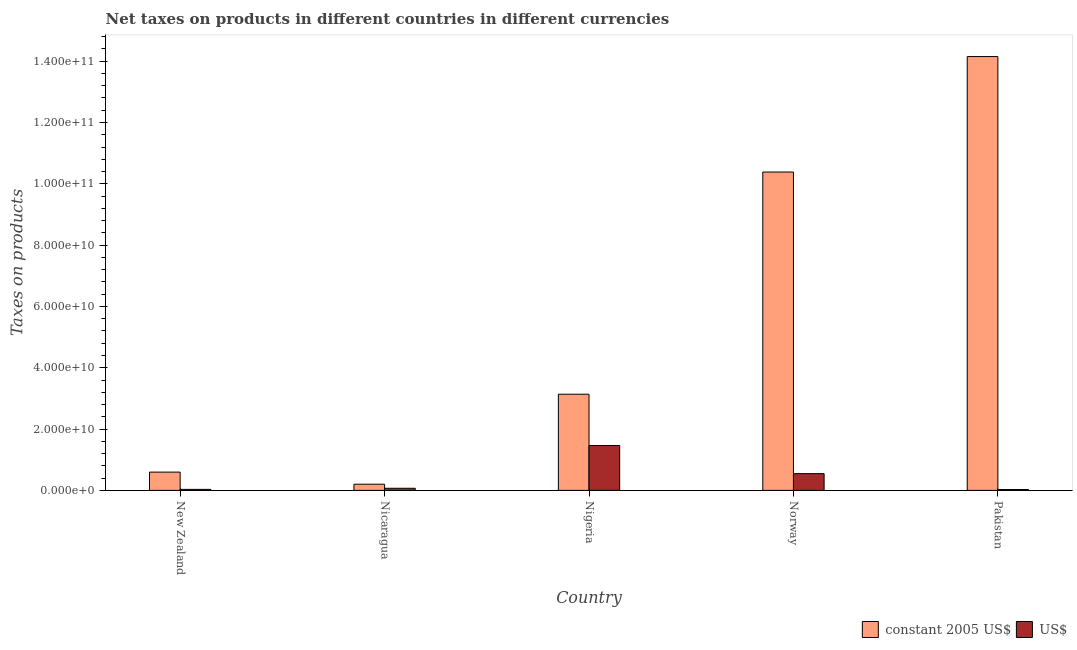How many different coloured bars are there?
Ensure brevity in your answer.  2. Are the number of bars per tick equal to the number of legend labels?
Your response must be concise. Yes. How many bars are there on the 3rd tick from the left?
Keep it short and to the point. 2. What is the label of the 1st group of bars from the left?
Keep it short and to the point. New Zealand. In how many cases, is the number of bars for a given country not equal to the number of legend labels?
Provide a short and direct response. 0. What is the net taxes in us$ in Nicaragua?
Your answer should be very brief. 6.93e+08. Across all countries, what is the maximum net taxes in constant 2005 us$?
Your answer should be compact. 1.42e+11. Across all countries, what is the minimum net taxes in constant 2005 us$?
Make the answer very short. 2.01e+09. In which country was the net taxes in constant 2005 us$ maximum?
Your answer should be very brief. Pakistan. In which country was the net taxes in us$ minimum?
Your answer should be very brief. Pakistan. What is the total net taxes in constant 2005 us$ in the graph?
Give a very brief answer. 2.85e+11. What is the difference between the net taxes in us$ in New Zealand and that in Pakistan?
Keep it short and to the point. 4.77e+07. What is the difference between the net taxes in constant 2005 us$ in Norway and the net taxes in us$ in Nigeria?
Keep it short and to the point. 8.92e+1. What is the average net taxes in us$ per country?
Keep it short and to the point. 4.28e+09. What is the difference between the net taxes in constant 2005 us$ and net taxes in us$ in Nicaragua?
Your answer should be compact. 1.32e+09. In how many countries, is the net taxes in constant 2005 us$ greater than 136000000000 units?
Offer a very short reply. 1. What is the ratio of the net taxes in us$ in New Zealand to that in Pakistan?
Offer a very short reply. 1.17. What is the difference between the highest and the second highest net taxes in constant 2005 us$?
Your answer should be compact. 3.77e+1. What is the difference between the highest and the lowest net taxes in constant 2005 us$?
Your response must be concise. 1.39e+11. In how many countries, is the net taxes in constant 2005 us$ greater than the average net taxes in constant 2005 us$ taken over all countries?
Your answer should be compact. 2. Is the sum of the net taxes in us$ in Nigeria and Pakistan greater than the maximum net taxes in constant 2005 us$ across all countries?
Ensure brevity in your answer.  No. What does the 1st bar from the left in Pakistan represents?
Provide a succinct answer. Constant 2005 us$. What does the 1st bar from the right in Pakistan represents?
Make the answer very short. US$. What is the difference between two consecutive major ticks on the Y-axis?
Ensure brevity in your answer.  2.00e+1. Does the graph contain any zero values?
Your answer should be compact. No. Does the graph contain grids?
Your answer should be very brief. No. What is the title of the graph?
Give a very brief answer. Net taxes on products in different countries in different currencies. What is the label or title of the Y-axis?
Give a very brief answer. Taxes on products. What is the Taxes on products in constant 2005 US$ in New Zealand?
Your answer should be compact. 5.97e+09. What is the Taxes on products of US$ in New Zealand?
Your answer should be very brief. 3.29e+08. What is the Taxes on products of constant 2005 US$ in Nicaragua?
Provide a short and direct response. 2.01e+09. What is the Taxes on products of US$ in Nicaragua?
Offer a terse response. 6.93e+08. What is the Taxes on products of constant 2005 US$ in Nigeria?
Provide a short and direct response. 3.14e+1. What is the Taxes on products of US$ in Nigeria?
Give a very brief answer. 1.46e+1. What is the Taxes on products in constant 2005 US$ in Norway?
Make the answer very short. 1.04e+11. What is the Taxes on products in US$ in Norway?
Offer a very short reply. 5.46e+09. What is the Taxes on products of constant 2005 US$ in Pakistan?
Give a very brief answer. 1.42e+11. What is the Taxes on products of US$ in Pakistan?
Offer a terse response. 2.81e+08. Across all countries, what is the maximum Taxes on products of constant 2005 US$?
Give a very brief answer. 1.42e+11. Across all countries, what is the maximum Taxes on products in US$?
Keep it short and to the point. 1.46e+1. Across all countries, what is the minimum Taxes on products in constant 2005 US$?
Provide a succinct answer. 2.01e+09. Across all countries, what is the minimum Taxes on products in US$?
Provide a succinct answer. 2.81e+08. What is the total Taxes on products in constant 2005 US$ in the graph?
Your response must be concise. 2.85e+11. What is the total Taxes on products of US$ in the graph?
Offer a very short reply. 2.14e+1. What is the difference between the Taxes on products in constant 2005 US$ in New Zealand and that in Nicaragua?
Your answer should be very brief. 3.95e+09. What is the difference between the Taxes on products of US$ in New Zealand and that in Nicaragua?
Offer a very short reply. -3.63e+08. What is the difference between the Taxes on products in constant 2005 US$ in New Zealand and that in Nigeria?
Offer a very short reply. -2.54e+1. What is the difference between the Taxes on products of US$ in New Zealand and that in Nigeria?
Make the answer very short. -1.43e+1. What is the difference between the Taxes on products in constant 2005 US$ in New Zealand and that in Norway?
Keep it short and to the point. -9.79e+1. What is the difference between the Taxes on products of US$ in New Zealand and that in Norway?
Provide a succinct answer. -5.14e+09. What is the difference between the Taxes on products of constant 2005 US$ in New Zealand and that in Pakistan?
Make the answer very short. -1.36e+11. What is the difference between the Taxes on products in US$ in New Zealand and that in Pakistan?
Offer a very short reply. 4.77e+07. What is the difference between the Taxes on products of constant 2005 US$ in Nicaragua and that in Nigeria?
Keep it short and to the point. -2.94e+1. What is the difference between the Taxes on products of US$ in Nicaragua and that in Nigeria?
Provide a succinct answer. -1.39e+1. What is the difference between the Taxes on products of constant 2005 US$ in Nicaragua and that in Norway?
Ensure brevity in your answer.  -1.02e+11. What is the difference between the Taxes on products in US$ in Nicaragua and that in Norway?
Your answer should be compact. -4.77e+09. What is the difference between the Taxes on products in constant 2005 US$ in Nicaragua and that in Pakistan?
Offer a terse response. -1.39e+11. What is the difference between the Taxes on products in US$ in Nicaragua and that in Pakistan?
Give a very brief answer. 4.11e+08. What is the difference between the Taxes on products in constant 2005 US$ in Nigeria and that in Norway?
Make the answer very short. -7.25e+1. What is the difference between the Taxes on products in US$ in Nigeria and that in Norway?
Your response must be concise. 9.17e+09. What is the difference between the Taxes on products in constant 2005 US$ in Nigeria and that in Pakistan?
Your answer should be very brief. -1.10e+11. What is the difference between the Taxes on products of US$ in Nigeria and that in Pakistan?
Provide a short and direct response. 1.44e+1. What is the difference between the Taxes on products of constant 2005 US$ in Norway and that in Pakistan?
Provide a short and direct response. -3.77e+1. What is the difference between the Taxes on products of US$ in Norway and that in Pakistan?
Offer a very short reply. 5.18e+09. What is the difference between the Taxes on products in constant 2005 US$ in New Zealand and the Taxes on products in US$ in Nicaragua?
Keep it short and to the point. 5.27e+09. What is the difference between the Taxes on products of constant 2005 US$ in New Zealand and the Taxes on products of US$ in Nigeria?
Offer a terse response. -8.67e+09. What is the difference between the Taxes on products in constant 2005 US$ in New Zealand and the Taxes on products in US$ in Norway?
Your answer should be compact. 5.02e+08. What is the difference between the Taxes on products of constant 2005 US$ in New Zealand and the Taxes on products of US$ in Pakistan?
Provide a succinct answer. 5.69e+09. What is the difference between the Taxes on products of constant 2005 US$ in Nicaragua and the Taxes on products of US$ in Nigeria?
Make the answer very short. -1.26e+1. What is the difference between the Taxes on products of constant 2005 US$ in Nicaragua and the Taxes on products of US$ in Norway?
Your answer should be very brief. -3.45e+09. What is the difference between the Taxes on products in constant 2005 US$ in Nicaragua and the Taxes on products in US$ in Pakistan?
Provide a succinct answer. 1.73e+09. What is the difference between the Taxes on products in constant 2005 US$ in Nigeria and the Taxes on products in US$ in Norway?
Make the answer very short. 2.59e+1. What is the difference between the Taxes on products in constant 2005 US$ in Nigeria and the Taxes on products in US$ in Pakistan?
Your answer should be very brief. 3.11e+1. What is the difference between the Taxes on products in constant 2005 US$ in Norway and the Taxes on products in US$ in Pakistan?
Your response must be concise. 1.04e+11. What is the average Taxes on products in constant 2005 US$ per country?
Offer a very short reply. 5.69e+1. What is the average Taxes on products in US$ per country?
Make the answer very short. 4.28e+09. What is the difference between the Taxes on products of constant 2005 US$ and Taxes on products of US$ in New Zealand?
Make the answer very short. 5.64e+09. What is the difference between the Taxes on products in constant 2005 US$ and Taxes on products in US$ in Nicaragua?
Provide a short and direct response. 1.32e+09. What is the difference between the Taxes on products of constant 2005 US$ and Taxes on products of US$ in Nigeria?
Keep it short and to the point. 1.67e+1. What is the difference between the Taxes on products of constant 2005 US$ and Taxes on products of US$ in Norway?
Your answer should be very brief. 9.84e+1. What is the difference between the Taxes on products in constant 2005 US$ and Taxes on products in US$ in Pakistan?
Give a very brief answer. 1.41e+11. What is the ratio of the Taxes on products in constant 2005 US$ in New Zealand to that in Nicaragua?
Ensure brevity in your answer.  2.96. What is the ratio of the Taxes on products in US$ in New Zealand to that in Nicaragua?
Provide a short and direct response. 0.48. What is the ratio of the Taxes on products of constant 2005 US$ in New Zealand to that in Nigeria?
Your response must be concise. 0.19. What is the ratio of the Taxes on products in US$ in New Zealand to that in Nigeria?
Ensure brevity in your answer.  0.02. What is the ratio of the Taxes on products in constant 2005 US$ in New Zealand to that in Norway?
Your answer should be compact. 0.06. What is the ratio of the Taxes on products in US$ in New Zealand to that in Norway?
Offer a terse response. 0.06. What is the ratio of the Taxes on products of constant 2005 US$ in New Zealand to that in Pakistan?
Make the answer very short. 0.04. What is the ratio of the Taxes on products of US$ in New Zealand to that in Pakistan?
Your answer should be compact. 1.17. What is the ratio of the Taxes on products of constant 2005 US$ in Nicaragua to that in Nigeria?
Ensure brevity in your answer.  0.06. What is the ratio of the Taxes on products of US$ in Nicaragua to that in Nigeria?
Give a very brief answer. 0.05. What is the ratio of the Taxes on products of constant 2005 US$ in Nicaragua to that in Norway?
Your answer should be very brief. 0.02. What is the ratio of the Taxes on products in US$ in Nicaragua to that in Norway?
Provide a succinct answer. 0.13. What is the ratio of the Taxes on products of constant 2005 US$ in Nicaragua to that in Pakistan?
Make the answer very short. 0.01. What is the ratio of the Taxes on products of US$ in Nicaragua to that in Pakistan?
Provide a short and direct response. 2.46. What is the ratio of the Taxes on products in constant 2005 US$ in Nigeria to that in Norway?
Your answer should be very brief. 0.3. What is the ratio of the Taxes on products in US$ in Nigeria to that in Norway?
Your response must be concise. 2.68. What is the ratio of the Taxes on products in constant 2005 US$ in Nigeria to that in Pakistan?
Keep it short and to the point. 0.22. What is the ratio of the Taxes on products in US$ in Nigeria to that in Pakistan?
Keep it short and to the point. 52.02. What is the ratio of the Taxes on products in constant 2005 US$ in Norway to that in Pakistan?
Offer a very short reply. 0.73. What is the ratio of the Taxes on products of US$ in Norway to that in Pakistan?
Ensure brevity in your answer.  19.42. What is the difference between the highest and the second highest Taxes on products of constant 2005 US$?
Offer a very short reply. 3.77e+1. What is the difference between the highest and the second highest Taxes on products of US$?
Your answer should be compact. 9.17e+09. What is the difference between the highest and the lowest Taxes on products of constant 2005 US$?
Make the answer very short. 1.39e+11. What is the difference between the highest and the lowest Taxes on products of US$?
Ensure brevity in your answer.  1.44e+1. 